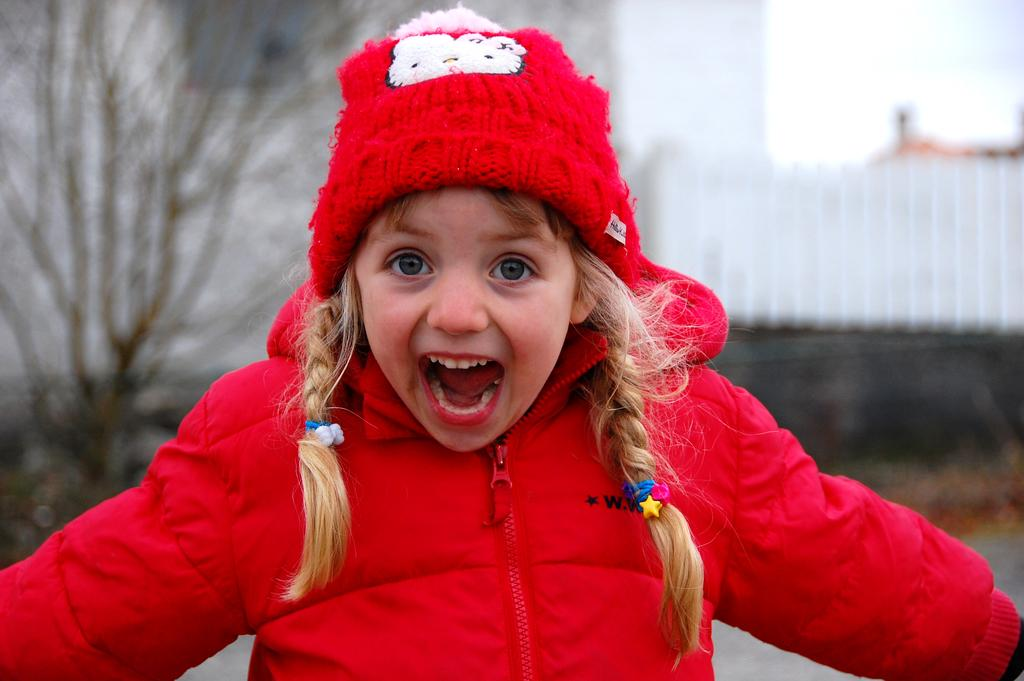What is the main subject of the image? There is a baby girl in the image. What is the baby girl wearing? The baby girl is wearing a red jacket. What is the baby girl doing in the image? The baby girl is shouting. What can be seen on the left side of the image? There is a tree on the left side of the image. What type of disease is affecting the baby girl in the image? There is no indication of any disease affecting the baby girl in the image. What is the baby girl using to eat the straw in the image? There is no straw present in the image. 